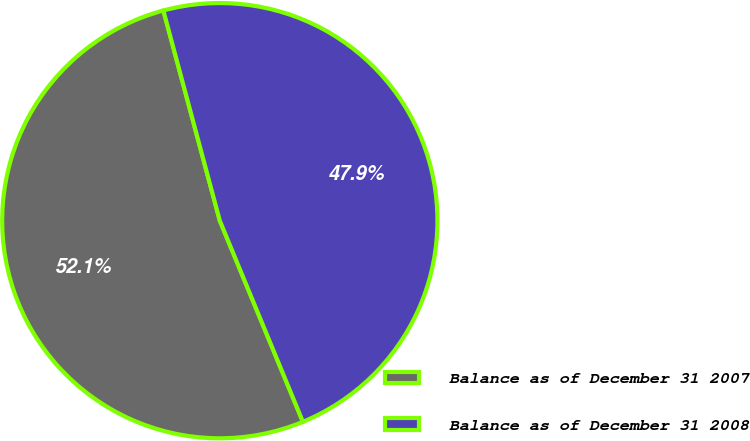Convert chart. <chart><loc_0><loc_0><loc_500><loc_500><pie_chart><fcel>Balance as of December 31 2007<fcel>Balance as of December 31 2008<nl><fcel>52.06%<fcel>47.94%<nl></chart> 